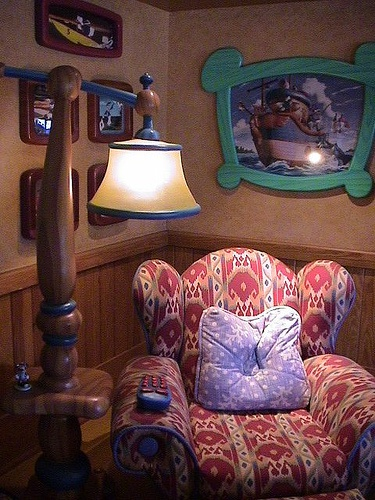Describe the objects in this image and their specific colors. I can see chair in maroon, black, brown, and lightpink tones and remote in maroon, black, navy, and purple tones in this image. 